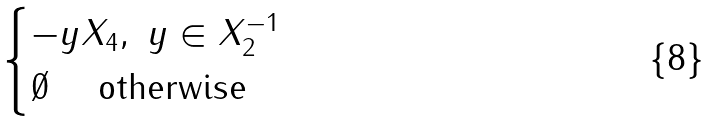Convert formula to latex. <formula><loc_0><loc_0><loc_500><loc_500>\begin{cases} - y X _ { 4 } , \ y \in X _ { 2 } ^ { - 1 } \\ \emptyset \quad \text { otherwise} \end{cases}</formula> 